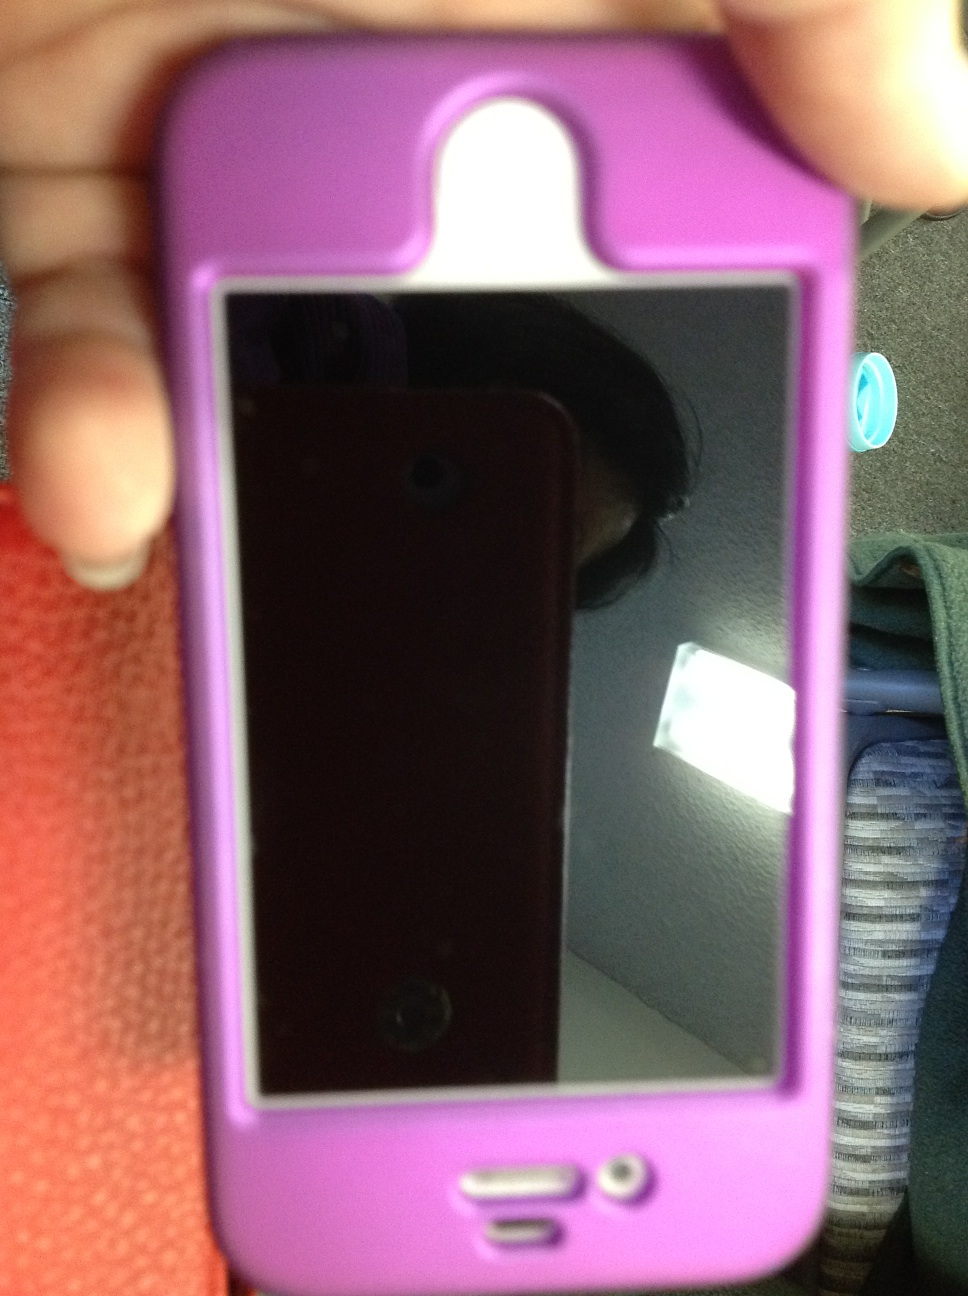If we were in a futuristic sci-fi universe, how would this phone be used? In a futuristic sci-fi universe, this phone could be far more advanced than it is today. Imagine it as a multi-functional device that not only communicates but also projects holographic images, videos, and virtual assistants into the air. It could translate languages in real-time, control smart devices with voice commands, and even perform advanced health diagnostics by scanning your body. This phone might be used to navigate through augmented reality environments, access global information networks instantly, and interface with artificial intelligence systems. The protective case could also have upgrades, perhaps offering energy shield capabilities or transforming into a mini drone for aerial perspectives. What if this phone had a hidden superpower? If this phone had a hidden superpower, it could activate an emergency teleportation function. In times of danger or distress, a simple combination of buttons could initiate a teleportation sequence, whisking the user away to a pre-set safe location. This superpower could be a closely guarded secret, known only to its owner, and used only in situations where swift escape is necessary. The phone would also disguise this feature well, with no outward hints, making it look just like any other regular device. 